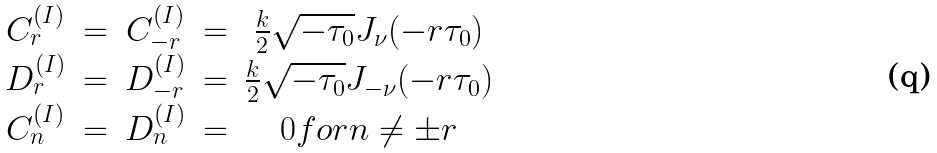Convert formula to latex. <formula><loc_0><loc_0><loc_500><loc_500>\begin{array} { c c c c c } C _ { r } ^ { ( I ) } & = & C _ { - r } ^ { ( I ) } & = & \frac { k } { 2 } \sqrt { - \tau _ { 0 } } J _ { \nu } ( - r \tau _ { 0 } ) \\ D _ { r } ^ { ( I ) } & = & D _ { - r } ^ { ( I ) } & = & \frac { k } { 2 } \sqrt { - \tau _ { 0 } } J _ { - \nu } ( - r \tau _ { 0 } ) \\ C _ { n } ^ { ( I ) } & = & D _ { n } ^ { ( I ) } & = & 0 f o r n \neq \pm r \end{array}</formula> 